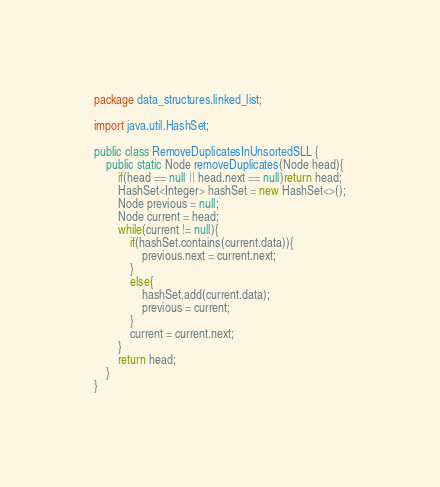Convert code to text. <code><loc_0><loc_0><loc_500><loc_500><_Java_>package data_structures.linked_list;

import java.util.HashSet;

public class RemoveDuplicatesInUnsortedSLL {
    public static Node removeDuplicates(Node head){
        if(head == null || head.next == null)return head;
        HashSet<Integer> hashSet = new HashSet<>();
        Node previous = null;
        Node current = head;
        while(current != null){
            if(hashSet.contains(current.data)){
                previous.next = current.next;
            }
            else{
                hashSet.add(current.data);
                previous = current;
            }
            current = current.next;
        }
        return head;
    }
}
</code> 